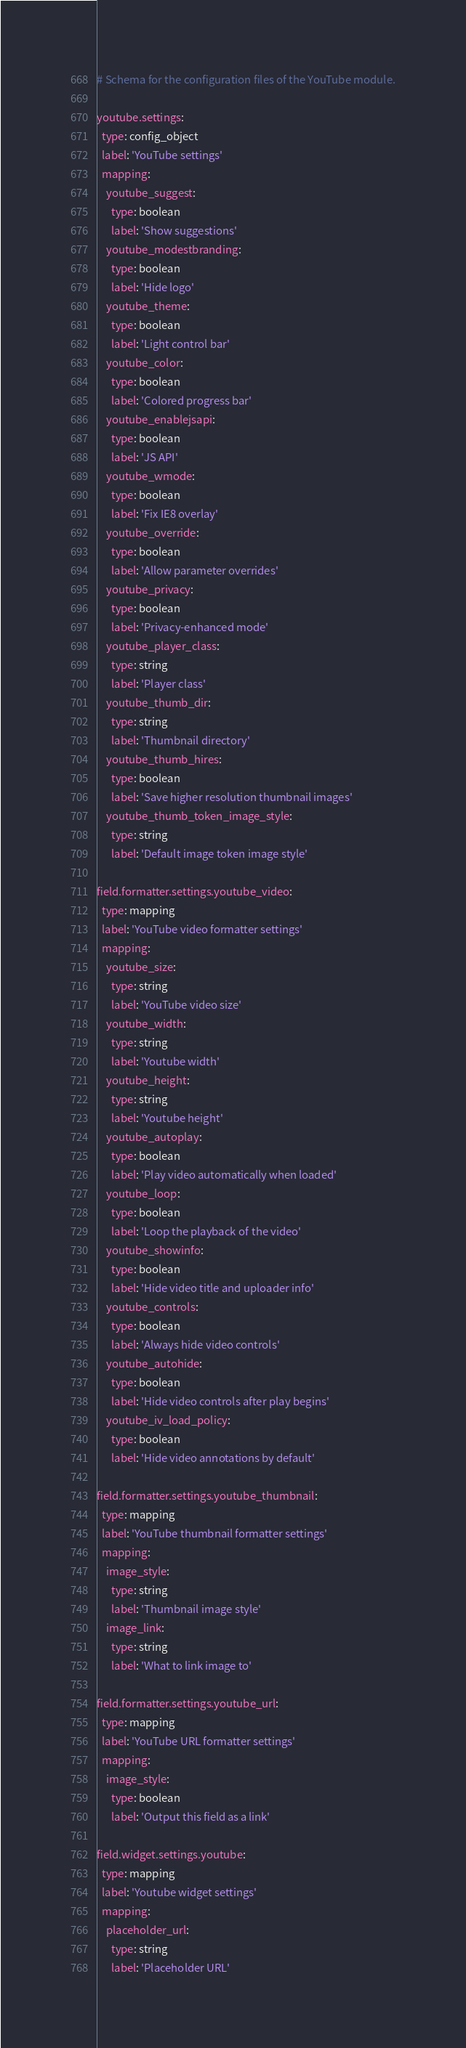Convert code to text. <code><loc_0><loc_0><loc_500><loc_500><_YAML_># Schema for the configuration files of the YouTube module.

youtube.settings:
  type: config_object
  label: 'YouTube settings'
  mapping:
    youtube_suggest:
      type: boolean
      label: 'Show suggestions'
    youtube_modestbranding:
      type: boolean
      label: 'Hide logo'
    youtube_theme:
      type: boolean
      label: 'Light control bar'
    youtube_color:
      type: boolean
      label: 'Colored progress bar'
    youtube_enablejsapi:
      type: boolean
      label: 'JS API'
    youtube_wmode:
      type: boolean
      label: 'Fix IE8 overlay'
    youtube_override:
      type: boolean
      label: 'Allow parameter overrides'
    youtube_privacy:
      type: boolean
      label: 'Privacy-enhanced mode'
    youtube_player_class:
      type: string
      label: 'Player class'
    youtube_thumb_dir:
      type: string
      label: 'Thumbnail directory'
    youtube_thumb_hires:
      type: boolean
      label: 'Save higher resolution thumbnail images'
    youtube_thumb_token_image_style:
      type: string
      label: 'Default image token image style'

field.formatter.settings.youtube_video:
  type: mapping
  label: 'YouTube video formatter settings'
  mapping:
    youtube_size:
      type: string
      label: 'YouTube video size'
    youtube_width:
      type: string
      label: 'Youtube width'
    youtube_height:
      type: string
      label: 'Youtube height'
    youtube_autoplay:
      type: boolean
      label: 'Play video automatically when loaded'
    youtube_loop:
      type: boolean
      label: 'Loop the playback of the video'
    youtube_showinfo:
      type: boolean
      label: 'Hide video title and uploader info'
    youtube_controls:
      type: boolean
      label: 'Always hide video controls'
    youtube_autohide:
      type: boolean
      label: 'Hide video controls after play begins'
    youtube_iv_load_policy:
      type: boolean
      label: 'Hide video annotations by default'

field.formatter.settings.youtube_thumbnail:
  type: mapping
  label: 'YouTube thumbnail formatter settings'
  mapping:
    image_style:
      type: string
      label: 'Thumbnail image style'
    image_link:
      type: string
      label: 'What to link image to'

field.formatter.settings.youtube_url:
  type: mapping
  label: 'YouTube URL formatter settings'
  mapping:
    image_style:
      type: boolean
      label: 'Output this field as a link'

field.widget.settings.youtube:
  type: mapping
  label: 'Youtube widget settings'
  mapping:
    placeholder_url:
      type: string
      label: 'Placeholder URL'
</code> 